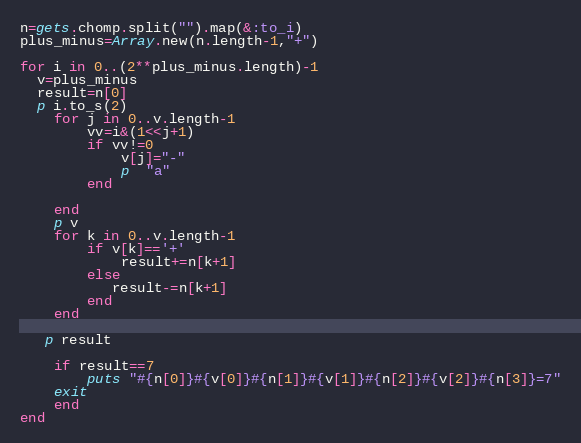Convert code to text. <code><loc_0><loc_0><loc_500><loc_500><_Ruby_>n=gets.chomp.split("").map(&:to_i)
plus_minus=Array.new(n.length-1,"+")

for i in 0..(2**plus_minus.length)-1
  v=plus_minus
  result=n[0]
  p i.to_s(2)
    for j in 0..v.length-1
        vv=i&(1<<j+1)
        if vv!=0
            v[j]="-"
            p  "a"
        end
            
    end
    p v
    for k in 0..v.length-1
        if v[k]=='+'
            result+=n[k+1]
        else
           result-=n[k+1]
        end
    end
  
   p result
    
    if result==7
        puts "#{n[0]}#{v[0]}#{n[1]}#{v[1]}#{n[2]}#{v[2]}#{n[3]}=7"
    exit
    end
end
</code> 